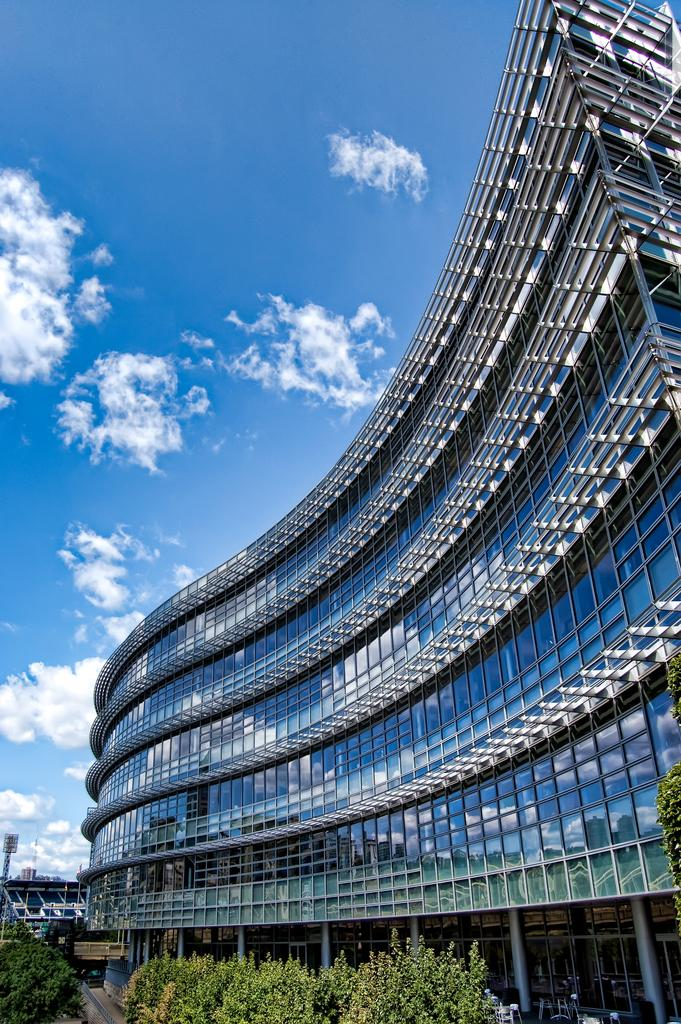What is the main structure in the image? There is a huge building in the image. What can be seen in front of the building? There are trees and plants in front of the building. What is visible in the background of the image? The sky is visible in the background of the image. What type of soda is being served at the peace rally in front of the building? There is no soda or peace rally present in the image; it only shows a huge building with trees and plants in front of it. 